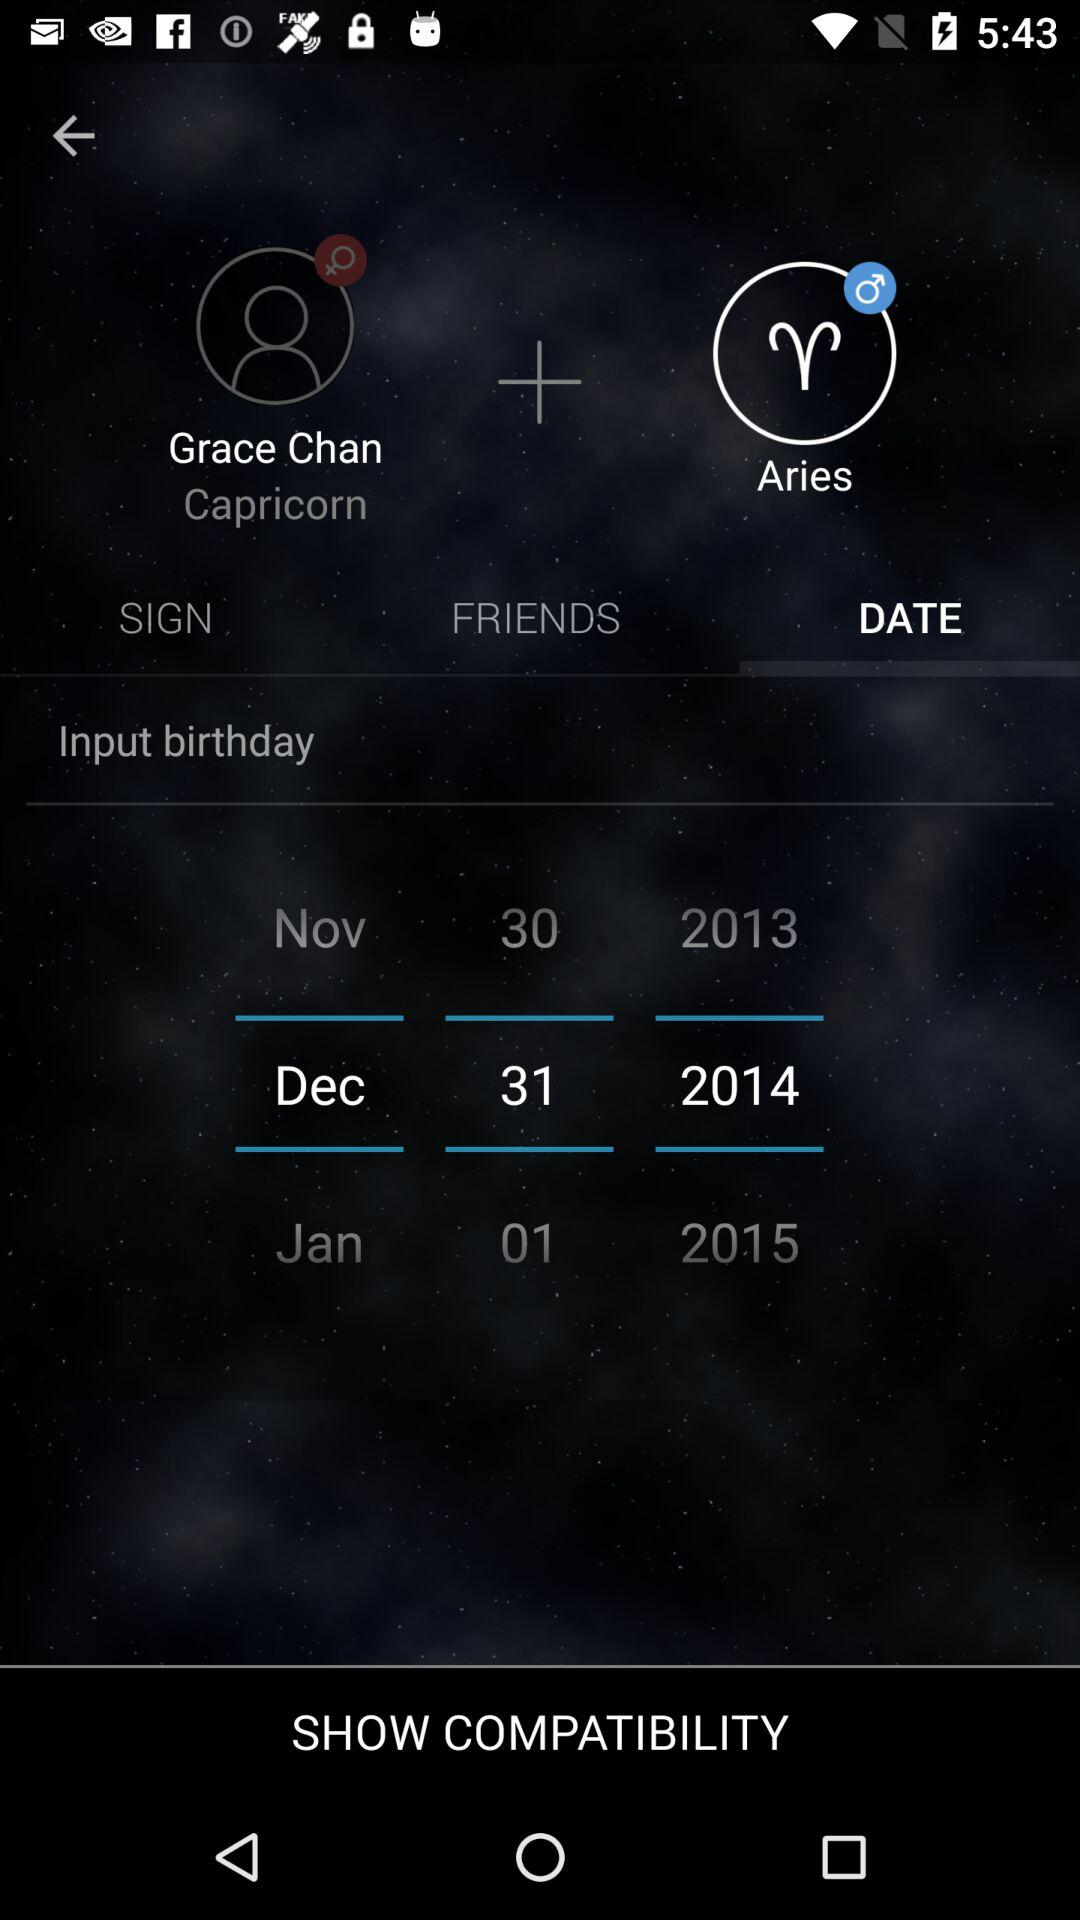What is the username? The username is "Grace Chan". 